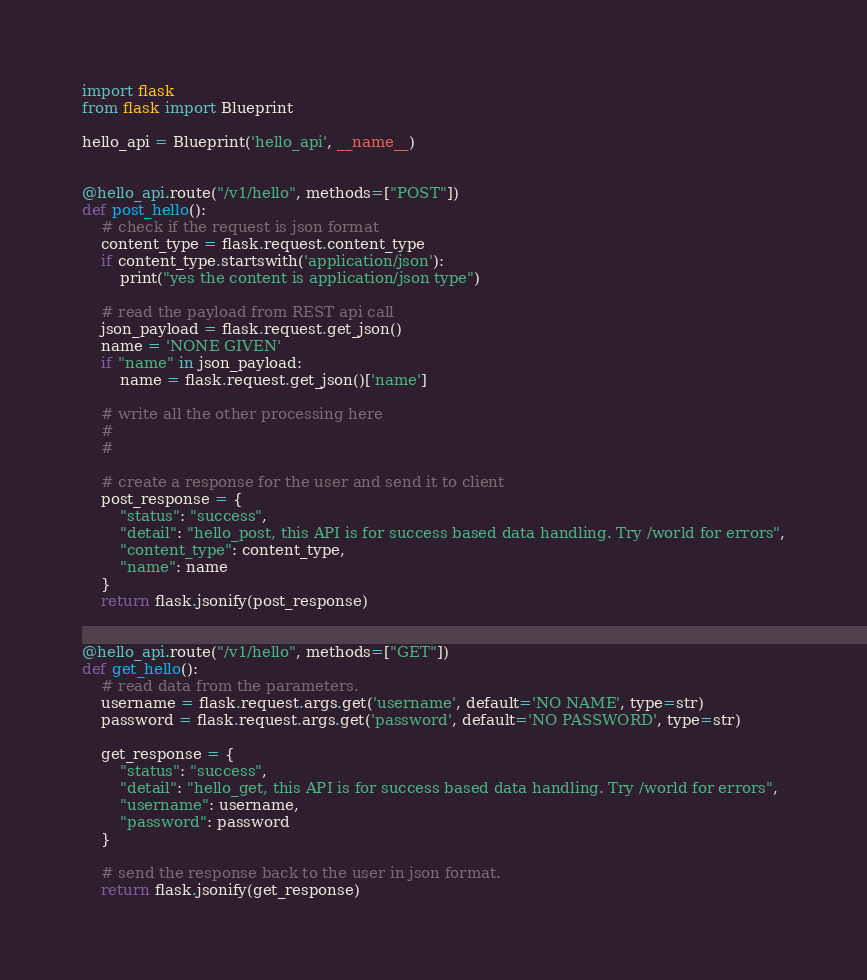<code> <loc_0><loc_0><loc_500><loc_500><_Python_>import flask
from flask import Blueprint

hello_api = Blueprint('hello_api', __name__)


@hello_api.route("/v1/hello", methods=["POST"])
def post_hello():
    # check if the request is json format
    content_type = flask.request.content_type
    if content_type.startswith('application/json'):
        print("yes the content is application/json type")

    # read the payload from REST api call
    json_payload = flask.request.get_json()
    name = 'NONE GIVEN'
    if "name" in json_payload:
        name = flask.request.get_json()['name']

    # write all the other processing here
    #
    #

    # create a response for the user and send it to client
    post_response = {
        "status": "success",
        "detail": "hello_post, this API is for success based data handling. Try /world for errors",
        "content_type": content_type,
        "name": name
    }
    return flask.jsonify(post_response)


@hello_api.route("/v1/hello", methods=["GET"])
def get_hello():
    # read data from the parameters.
    username = flask.request.args.get('username', default='NO NAME', type=str)
    password = flask.request.args.get('password', default='NO PASSWORD', type=str)

    get_response = {
        "status": "success",
        "detail": "hello_get, this API is for success based data handling. Try /world for errors",
        "username": username,
        "password": password
    }

    # send the response back to the user in json format.
    return flask.jsonify(get_response)
</code> 